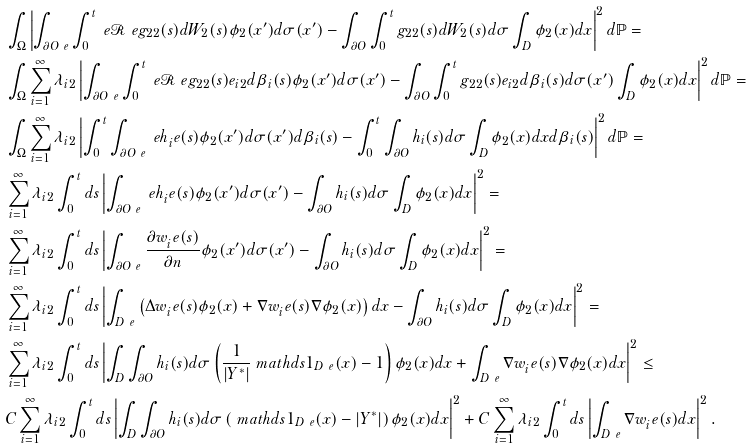Convert formula to latex. <formula><loc_0><loc_0><loc_500><loc_500>& \int _ { \Omega } \left | \int _ { \partial O ^ { \ } e } \int _ { 0 } ^ { t } \ e \mathcal { R } ^ { \ } e g _ { 2 2 } ( s ) d W _ { 2 } ( s ) \phi _ { 2 } ( x ^ { \prime } ) d \sigma ( x ^ { \prime } ) - \int _ { \partial O } \int _ { 0 } ^ { t } g _ { 2 2 } ( s ) d W _ { 2 } ( s ) d \sigma \int _ { D } \phi _ { 2 } ( x ) d x \right | ^ { 2 } d \mathbb { P } = \\ & \int _ { \Omega } \sum _ { i = 1 } ^ { \infty } \lambda _ { i 2 } \left | \int _ { \partial O ^ { \ } e } \int _ { 0 } ^ { t } \ e \mathcal { R } ^ { \ } e g _ { 2 2 } ( s ) e _ { i 2 } d \beta _ { i } ( s ) \phi _ { 2 } ( x ^ { \prime } ) d \sigma ( x ^ { \prime } ) - \int _ { \partial O } \int _ { 0 } ^ { t } g _ { 2 2 } ( s ) e _ { i 2 } d \beta _ { i } ( s ) d \sigma ( x ^ { \prime } ) \int _ { D } \phi _ { 2 } ( x ) d x \right | ^ { 2 } d \mathbb { P } = \\ & \int _ { \Omega } \sum _ { i = 1 } ^ { \infty } \lambda _ { i 2 } \left | \int _ { 0 } ^ { t } \int _ { \partial O ^ { \ } e } \ e h _ { i } ^ { \ } e ( s ) \phi _ { 2 } ( x ^ { \prime } ) d \sigma ( x ^ { \prime } ) d \beta _ { i } ( s ) - \int _ { 0 } ^ { t } \int _ { \partial O } h _ { i } ( s ) d \sigma \int _ { D } \phi _ { 2 } ( x ) d x d \beta _ { i } ( s ) \right | ^ { 2 } d \mathbb { P } = \\ & \sum _ { i = 1 } ^ { \infty } \lambda _ { i 2 } \int _ { 0 } ^ { t } d s \left | \int _ { \partial O ^ { \ } e } \ e h _ { i } ^ { \ } e ( s ) \phi _ { 2 } ( x ^ { \prime } ) d \sigma ( x ^ { \prime } ) - \int _ { \partial O } h _ { i } ( s ) d \sigma \int _ { D } \phi _ { 2 } ( x ) d x \right | ^ { 2 } = \\ & \sum _ { i = 1 } ^ { \infty } \lambda _ { i 2 } \int _ { 0 } ^ { t } d s \left | \int _ { \partial O ^ { \ } e } \frac { \partial w _ { i } ^ { \ } e ( s ) } { \partial n } \phi _ { 2 } ( x ^ { \prime } ) d \sigma ( x ^ { \prime } ) - \int _ { \partial O } h _ { i } ( s ) d \sigma \int _ { D } \phi _ { 2 } ( x ) d x \right | ^ { 2 } = \\ & \sum _ { i = 1 } ^ { \infty } \lambda _ { i 2 } \int _ { 0 } ^ { t } d s \left | \int _ { D ^ { \ } e } \left ( \Delta w _ { i } ^ { \ } e ( s ) \phi _ { 2 } ( x ) + \nabla w _ { i } ^ { \ } e ( s ) \nabla \phi _ { 2 } ( x ) \right ) d x - \int _ { \partial O } h _ { i } ( s ) d \sigma \int _ { D } \phi _ { 2 } ( x ) d x \right | ^ { 2 } = \\ & \sum _ { i = 1 } ^ { \infty } \lambda _ { i 2 } \int _ { 0 } ^ { t } d s \left | \int _ { D } \int _ { \partial O } h _ { i } ( s ) d \sigma \left ( \frac { 1 } { | Y ^ { * } | } \ m a t h d s { 1 } _ { D ^ { \ } e } ( x ) - 1 \right ) \phi _ { 2 } ( x ) d x + \int _ { D ^ { \ } e } \nabla w _ { i } ^ { \ } e ( s ) \nabla \phi _ { 2 } ( x ) d x \right | ^ { 2 } \leq \\ & C \sum _ { i = 1 } ^ { \infty } \lambda _ { i 2 } \int _ { 0 } ^ { t } d s \left | \int _ { D } \int _ { \partial O } h _ { i } ( s ) d \sigma \left ( \ m a t h d s { 1 } _ { D ^ { \ } e } ( x ) - | Y ^ { * } | \right ) \phi _ { 2 } ( x ) d x \right | ^ { 2 } + C \sum _ { i = 1 } ^ { \infty } \lambda _ { i 2 } \int _ { 0 } ^ { t } d s \left | \int _ { D ^ { \ } e } \nabla w _ { i } ^ { \ } e ( s ) d x \right | ^ { 2 } .</formula> 